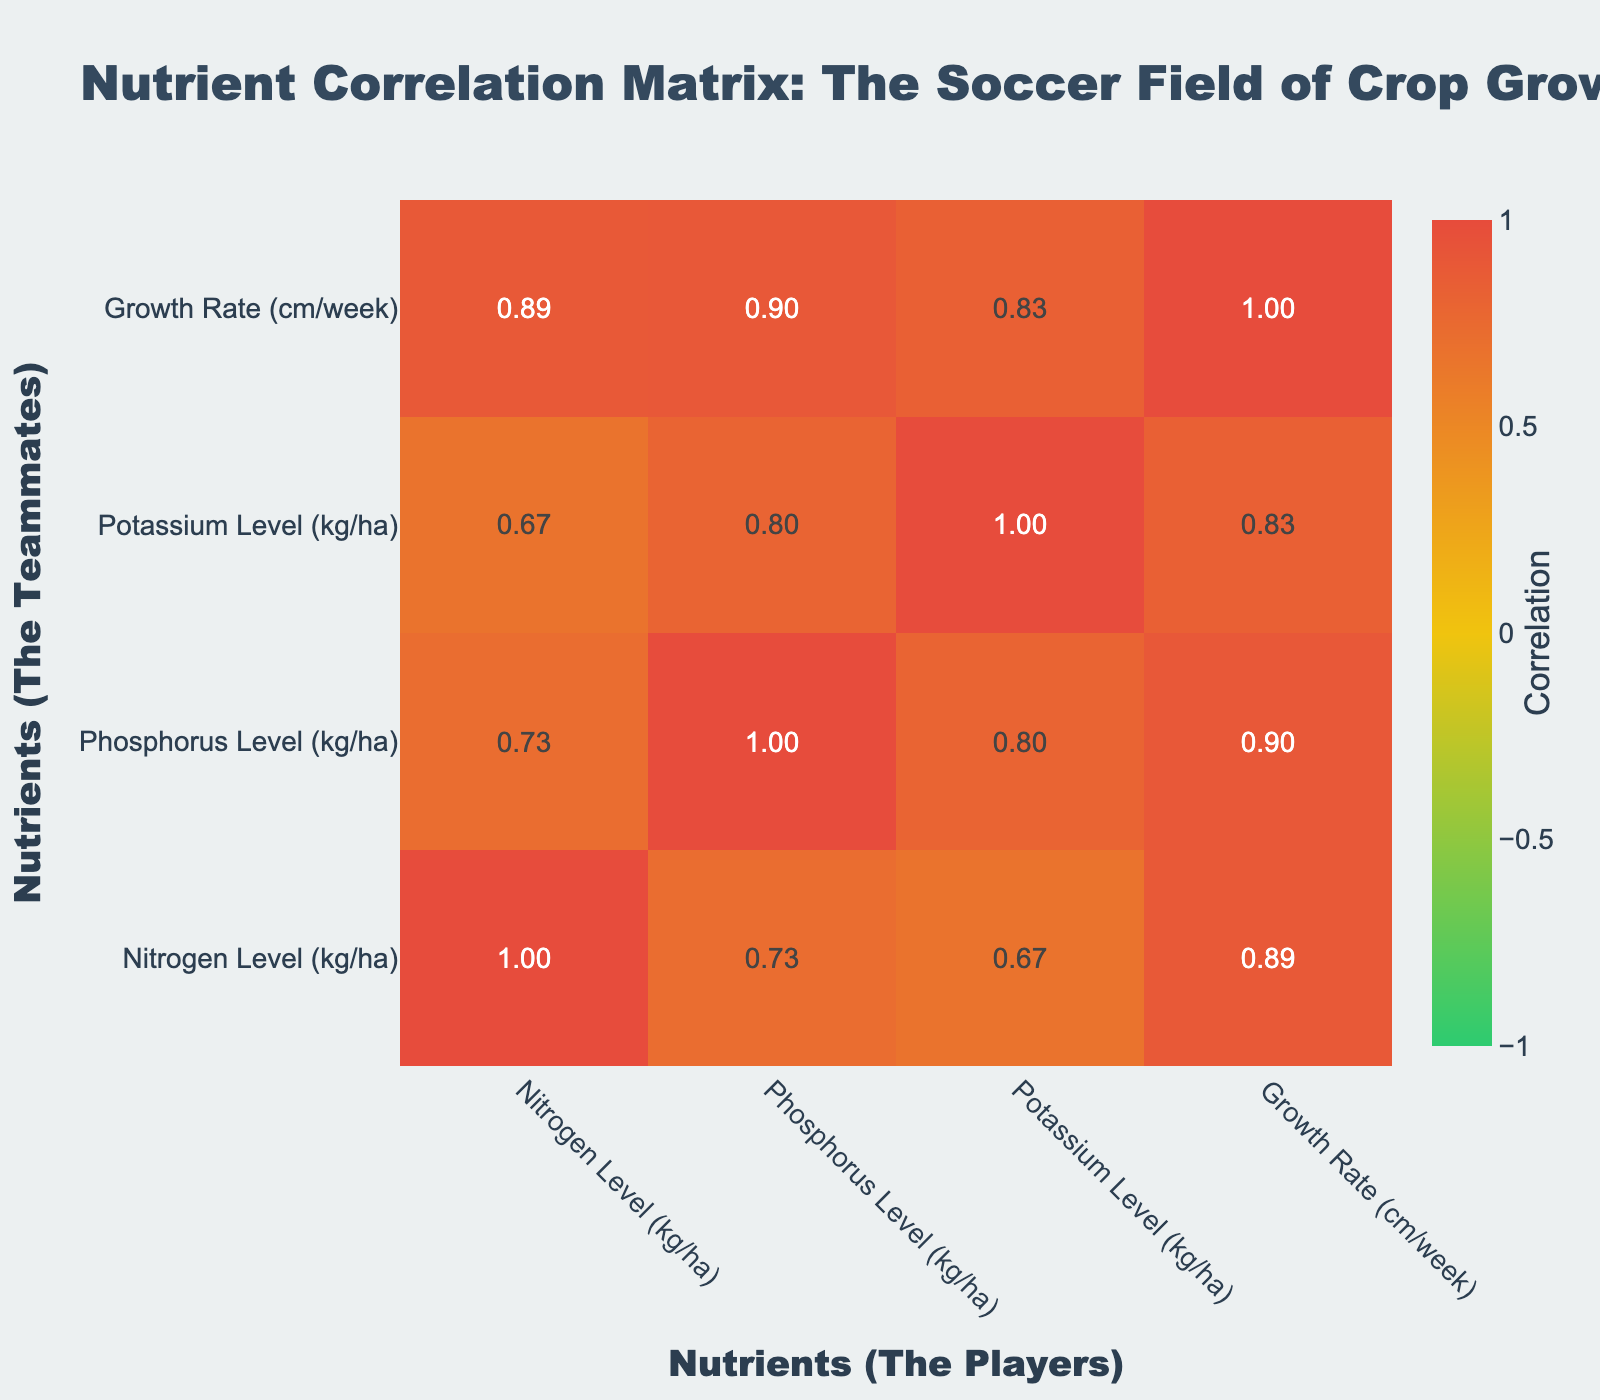What is the nitrogen level for tobacco? The nitrogen level for tobacco is directly stated in the table under the "Nitrogen Level (kg/ha)" column corresponding to the "Tobacco" row. It shows a value of 200 kg/ha.
Answer: 200 kg/ha Which crop has the highest growth rate? The growth rates for each crop are listed in the "Growth Rate (cm/week)" column. By comparing the values, tobacco has the highest growth rate at 6.0 cm/week.
Answer: Tobacco Is there a positive correlation between phosphorus and growth rate? To determine this, we check the correlation coefficient between the "Phosphorus Level (kg/ha)" and "Growth Rate (cm/week)" from the correlation table. A value greater than 0 indicates a positive correlation. The value is approximately 0.80, suggesting a strong positive correlation.
Answer: Yes What is the average nitrogen level of all crops? First, we sum the nitrogen levels for all crops: 150 + 120 + 200 + 100 + 160 + 140 + 90 + 130 + 110 = 1,200 kg/ha. Then, we divide this sum by the number of crops (9). Hence, the average nitrogen level is 1,200 / 9 = approximately 133.33 kg/ha.
Answer: 133.33 kg/ha Is the potassium level for rice greater than that for sorghum? We need to compare values in the "Potassium Level (kg/ha)" column for rice (75 kg/ha) and sorghum (50 kg/ha). Since 75 is greater than 50, rice has a higher potassium level than sorghum.
Answer: Yes What is the difference in growth rates between maize and sweet potato? The growth rate for maize is 5.2 cm/week, and for sweet potato, it is 3.8 cm/week. We calculate the difference as 5.2 - 3.8 = 1.4 cm/week.
Answer: 1.4 cm/week Which crop has the least phosphorus level? Looking at the "Phosphorus Level (kg/ha)" column, the lowest value is 10 kg/ha, which corresponds to pumpkin. Thus, pumpkin has the least phosphorus level.
Answer: Pumpkin What is the potassium level's average for all crops? First, sum the potassium levels for all crops: 80 + 60 + 70 + 50 + 65 + 55 + 45 + 75 + 40 = 610 kg/ha. Then, divide the total by the number of crops (9), giving 610 / 9 = approximately 67.78 kg/ha.
Answer: 67.78 kg/ha Does a higher nitrogen level correlate with a higher growth rate? To assess this, we observe the correlation coefficient between nitrogen levels and growth rates in the correlation table. The value is approximately 0.70, indicating a positive correlation whereby increased nitrogen levels tend to correspond to higher growth rates.
Answer: Yes 